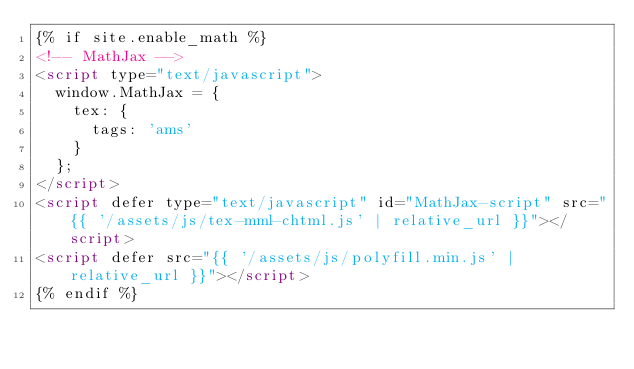<code> <loc_0><loc_0><loc_500><loc_500><_HTML_>{% if site.enable_math %}
<!-- MathJax -->
<script type="text/javascript">
  window.MathJax = {
    tex: {
      tags: 'ams'
    }
  };
</script>
<script defer type="text/javascript" id="MathJax-script" src="{{ '/assets/js/tex-mml-chtml.js' | relative_url }}"></script>
<script defer src="{{ '/assets/js/polyfill.min.js' | relative_url }}"></script>
{% endif %}
</code> 